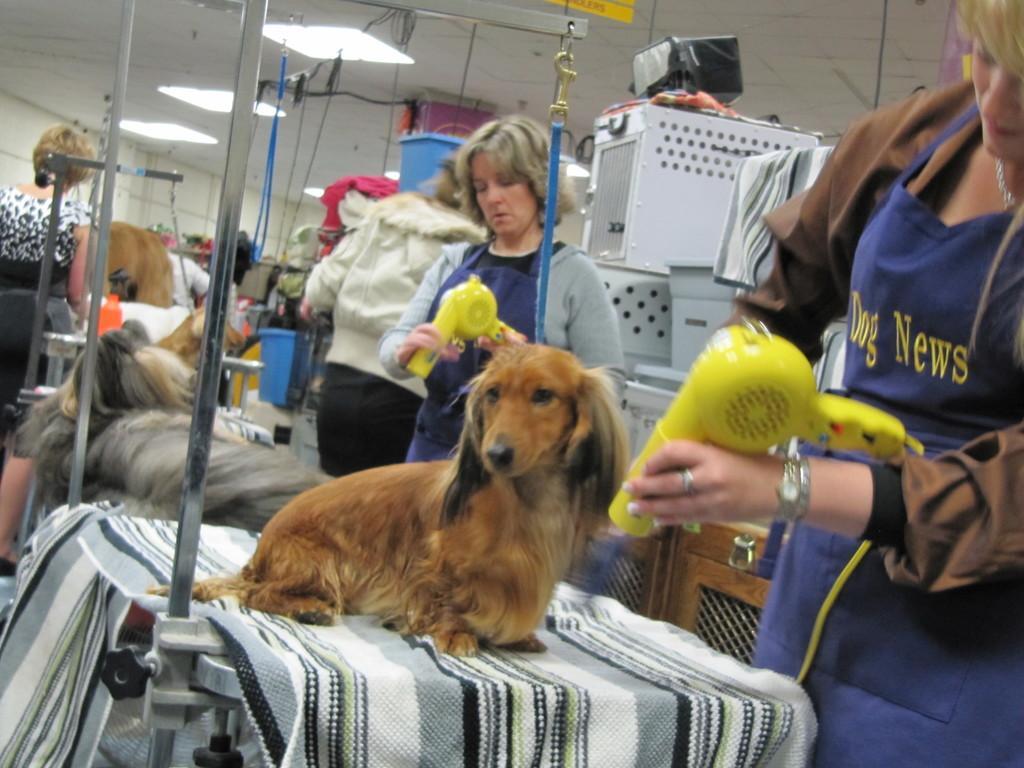Please provide a concise description of this image. It is a dog in brown color. on the right side a woman is standing and looking at this dog. 